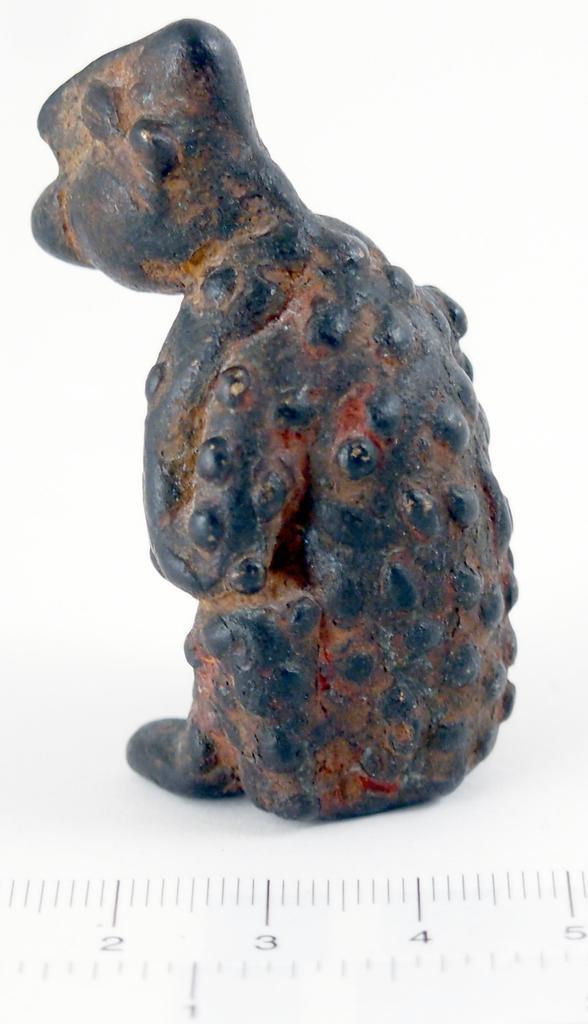How would you summarize this image in a sentence or two? In this image I can see the scale and the black and brown colored object. I can see the white colored background. 